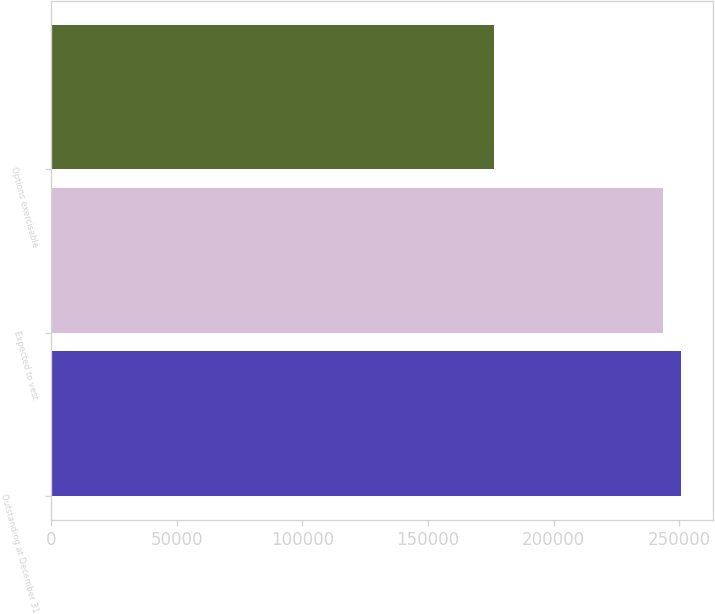<chart> <loc_0><loc_0><loc_500><loc_500><bar_chart><fcel>Outstanding at December 31<fcel>Expected to vest<fcel>Options exercisable<nl><fcel>250785<fcel>243461<fcel>176053<nl></chart> 